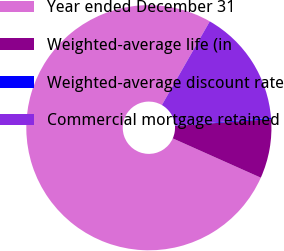<chart> <loc_0><loc_0><loc_500><loc_500><pie_chart><fcel>Year ended December 31<fcel>Weighted-average life (in<fcel>Weighted-average discount rate<fcel>Commercial mortgage retained<nl><fcel>76.59%<fcel>7.8%<fcel>0.16%<fcel>15.45%<nl></chart> 